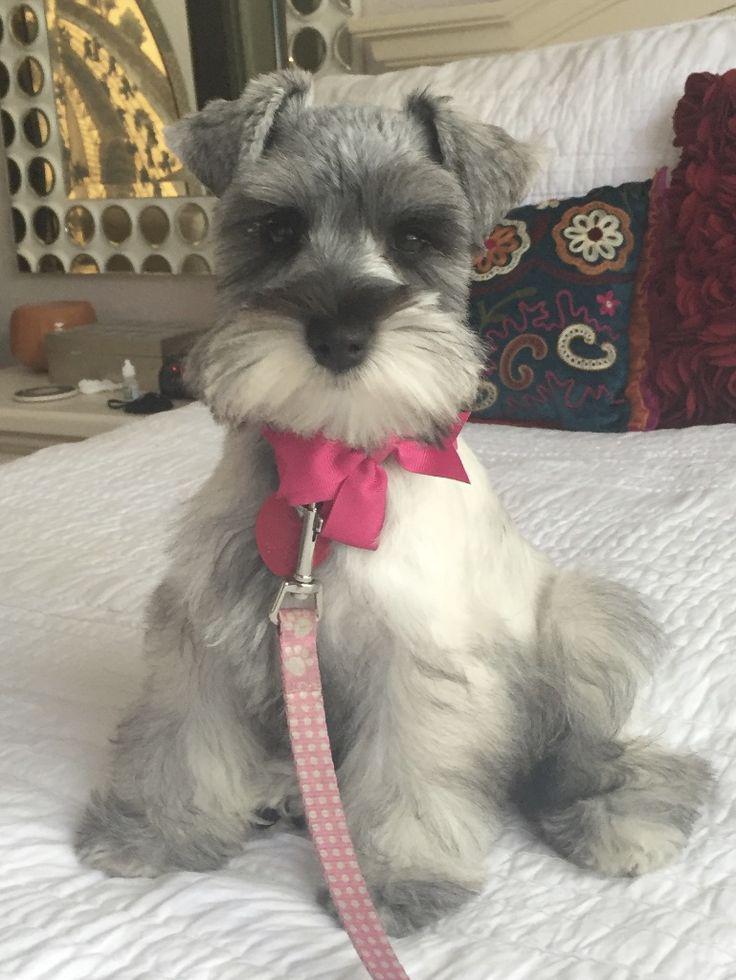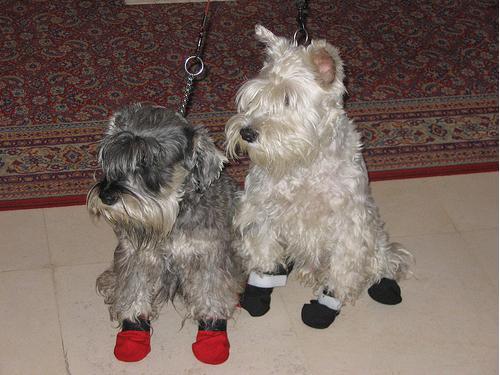The first image is the image on the left, the second image is the image on the right. Evaluate the accuracy of this statement regarding the images: "The left image shows a schnauzer with its rear to the camera, lying on its belly on a pillow, with its legs extended behind it and its head turned to the right.". Is it true? Answer yes or no. No. The first image is the image on the left, the second image is the image on the right. Evaluate the accuracy of this statement regarding the images: "All the dogs are laying on their stomachs.". Is it true? Answer yes or no. No. 